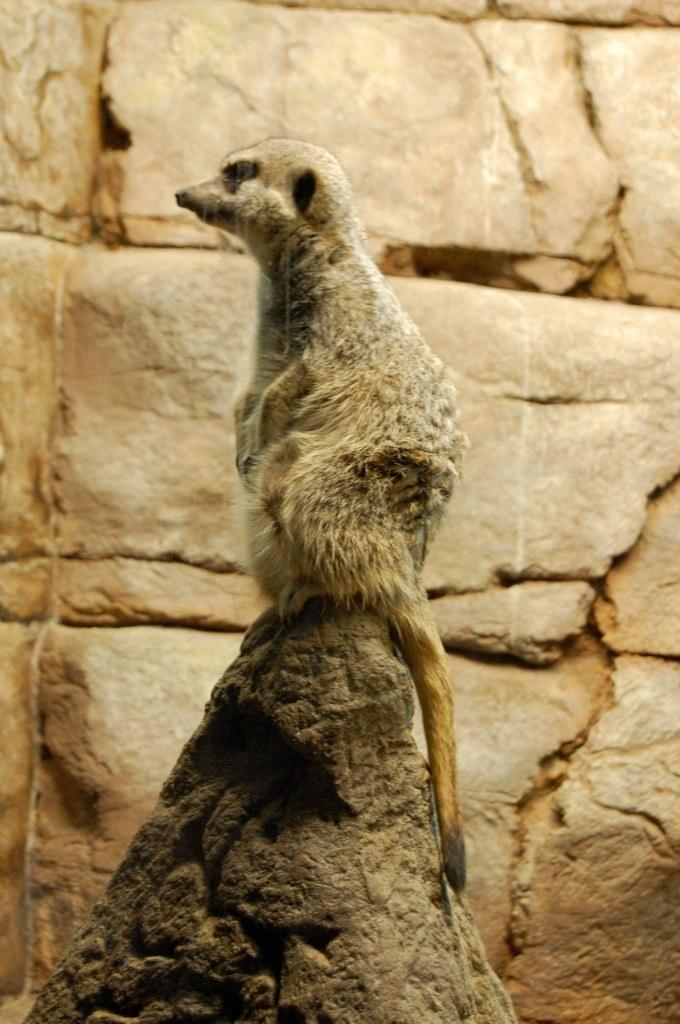What is the main subject of the image? There is an animal on a rock in the image. Can you describe the setting of the image? There is a wall in the background of the image. What type of cough does the animal have in the image? There is no indication of a cough in the image; the animal is simply sitting on a rock. What topic is being discussed by the animal in the image? There is no discussion taking place in the image; the animal is not depicted as engaging in any verbal communication. 